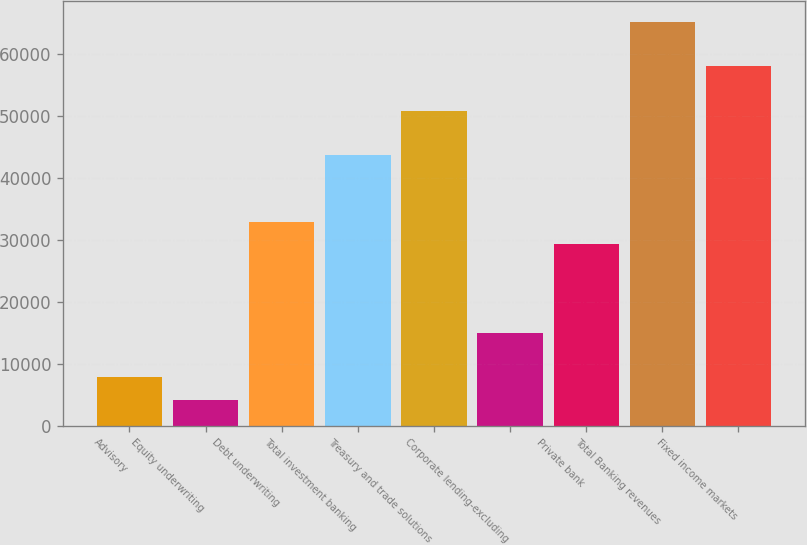Convert chart. <chart><loc_0><loc_0><loc_500><loc_500><bar_chart><fcel>Advisory<fcel>Equity underwriting<fcel>Debt underwriting<fcel>Total investment banking<fcel>Treasury and trade solutions<fcel>Corporate lending-excluding<fcel>Private bank<fcel>Total Banking revenues<fcel>Fixed income markets<nl><fcel>7807.6<fcel>4224.3<fcel>32890.7<fcel>43640.6<fcel>50807.2<fcel>14974.2<fcel>29307.4<fcel>65140.4<fcel>57973.8<nl></chart> 